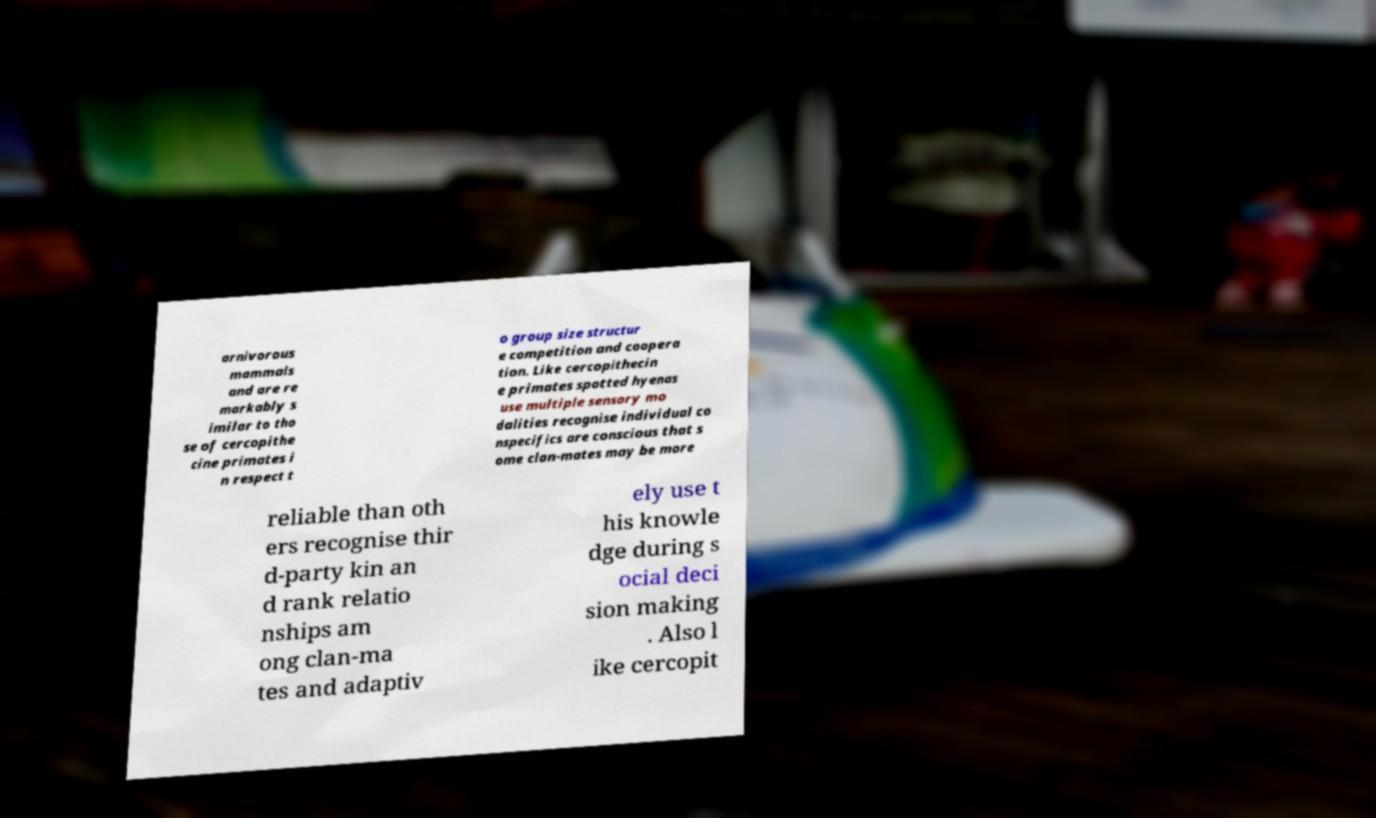Please read and relay the text visible in this image. What does it say? arnivorous mammals and are re markably s imilar to tho se of cercopithe cine primates i n respect t o group size structur e competition and coopera tion. Like cercopithecin e primates spotted hyenas use multiple sensory mo dalities recognise individual co nspecifics are conscious that s ome clan-mates may be more reliable than oth ers recognise thir d-party kin an d rank relatio nships am ong clan-ma tes and adaptiv ely use t his knowle dge during s ocial deci sion making . Also l ike cercopit 